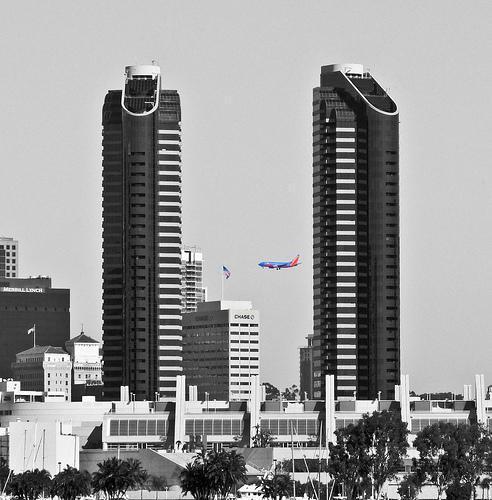How many planes are there?
Give a very brief answer. 1. 